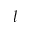Convert formula to latex. <formula><loc_0><loc_0><loc_500><loc_500>l</formula> 